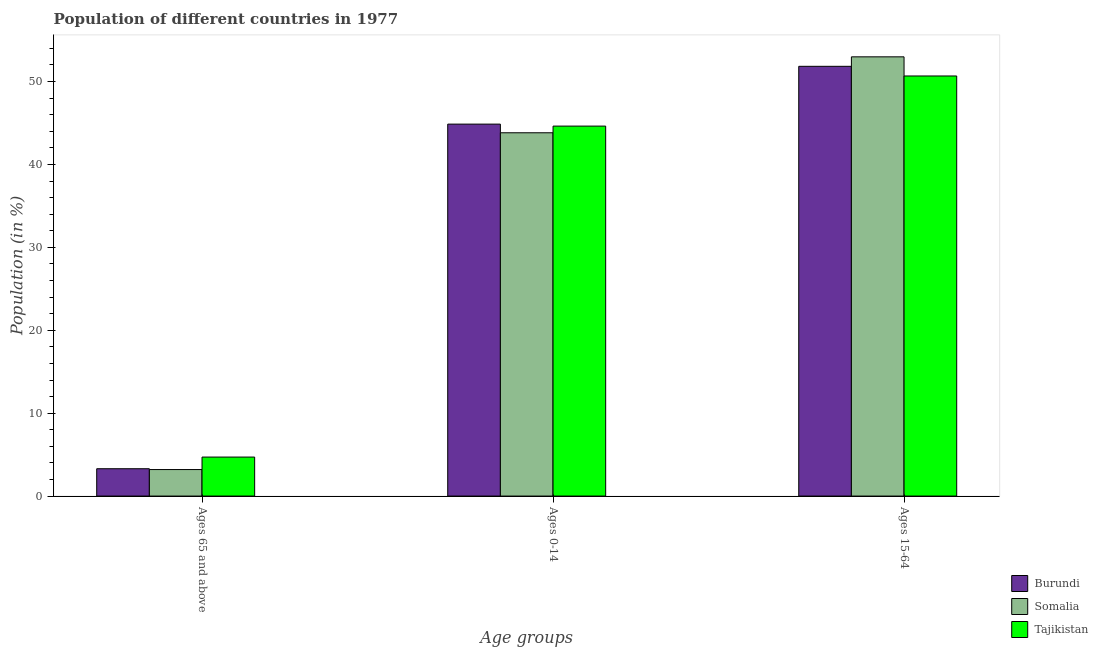How many different coloured bars are there?
Your response must be concise. 3. How many groups of bars are there?
Keep it short and to the point. 3. Are the number of bars per tick equal to the number of legend labels?
Your answer should be compact. Yes. What is the label of the 3rd group of bars from the left?
Keep it short and to the point. Ages 15-64. What is the percentage of population within the age-group 0-14 in Tajikistan?
Offer a terse response. 44.63. Across all countries, what is the maximum percentage of population within the age-group 15-64?
Provide a short and direct response. 52.98. Across all countries, what is the minimum percentage of population within the age-group of 65 and above?
Your response must be concise. 3.2. In which country was the percentage of population within the age-group of 65 and above maximum?
Your response must be concise. Tajikistan. In which country was the percentage of population within the age-group 15-64 minimum?
Provide a succinct answer. Tajikistan. What is the total percentage of population within the age-group 15-64 in the graph?
Offer a very short reply. 155.49. What is the difference between the percentage of population within the age-group 0-14 in Tajikistan and that in Burundi?
Provide a short and direct response. -0.24. What is the difference between the percentage of population within the age-group 0-14 in Somalia and the percentage of population within the age-group of 65 and above in Burundi?
Offer a terse response. 40.52. What is the average percentage of population within the age-group 15-64 per country?
Provide a short and direct response. 51.83. What is the difference between the percentage of population within the age-group 0-14 and percentage of population within the age-group 15-64 in Somalia?
Your response must be concise. -9.16. In how many countries, is the percentage of population within the age-group of 65 and above greater than 18 %?
Provide a short and direct response. 0. What is the ratio of the percentage of population within the age-group 0-14 in Tajikistan to that in Burundi?
Your answer should be compact. 0.99. Is the percentage of population within the age-group 15-64 in Tajikistan less than that in Somalia?
Offer a terse response. Yes. Is the difference between the percentage of population within the age-group 15-64 in Tajikistan and Somalia greater than the difference between the percentage of population within the age-group of 65 and above in Tajikistan and Somalia?
Offer a terse response. No. What is the difference between the highest and the second highest percentage of population within the age-group 15-64?
Offer a very short reply. 1.14. What is the difference between the highest and the lowest percentage of population within the age-group of 65 and above?
Make the answer very short. 1.51. In how many countries, is the percentage of population within the age-group 0-14 greater than the average percentage of population within the age-group 0-14 taken over all countries?
Provide a short and direct response. 2. Is the sum of the percentage of population within the age-group 15-64 in Somalia and Tajikistan greater than the maximum percentage of population within the age-group 0-14 across all countries?
Provide a succinct answer. Yes. What does the 2nd bar from the left in Ages 0-14 represents?
Provide a succinct answer. Somalia. What does the 3rd bar from the right in Ages 15-64 represents?
Provide a succinct answer. Burundi. Is it the case that in every country, the sum of the percentage of population within the age-group of 65 and above and percentage of population within the age-group 0-14 is greater than the percentage of population within the age-group 15-64?
Offer a terse response. No. Are all the bars in the graph horizontal?
Your answer should be compact. No. What is the difference between two consecutive major ticks on the Y-axis?
Offer a terse response. 10. Does the graph contain any zero values?
Make the answer very short. No. Does the graph contain grids?
Your answer should be compact. No. Where does the legend appear in the graph?
Ensure brevity in your answer.  Bottom right. How are the legend labels stacked?
Make the answer very short. Vertical. What is the title of the graph?
Keep it short and to the point. Population of different countries in 1977. What is the label or title of the X-axis?
Keep it short and to the point. Age groups. What is the Population (in %) in Burundi in Ages 65 and above?
Offer a terse response. 3.3. What is the Population (in %) in Somalia in Ages 65 and above?
Offer a very short reply. 3.2. What is the Population (in %) in Tajikistan in Ages 65 and above?
Provide a short and direct response. 4.7. What is the Population (in %) of Burundi in Ages 0-14?
Provide a succinct answer. 44.87. What is the Population (in %) in Somalia in Ages 0-14?
Provide a succinct answer. 43.82. What is the Population (in %) in Tajikistan in Ages 0-14?
Make the answer very short. 44.63. What is the Population (in %) of Burundi in Ages 15-64?
Provide a succinct answer. 51.84. What is the Population (in %) of Somalia in Ages 15-64?
Your answer should be compact. 52.98. What is the Population (in %) of Tajikistan in Ages 15-64?
Offer a very short reply. 50.67. Across all Age groups, what is the maximum Population (in %) of Burundi?
Ensure brevity in your answer.  51.84. Across all Age groups, what is the maximum Population (in %) in Somalia?
Your answer should be very brief. 52.98. Across all Age groups, what is the maximum Population (in %) of Tajikistan?
Your response must be concise. 50.67. Across all Age groups, what is the minimum Population (in %) in Burundi?
Your response must be concise. 3.3. Across all Age groups, what is the minimum Population (in %) in Somalia?
Your answer should be very brief. 3.2. Across all Age groups, what is the minimum Population (in %) of Tajikistan?
Provide a short and direct response. 4.7. What is the total Population (in %) of Burundi in the graph?
Give a very brief answer. 100. What is the total Population (in %) in Somalia in the graph?
Provide a short and direct response. 100. What is the difference between the Population (in %) in Burundi in Ages 65 and above and that in Ages 0-14?
Your answer should be compact. -41.57. What is the difference between the Population (in %) of Somalia in Ages 65 and above and that in Ages 0-14?
Your answer should be compact. -40.62. What is the difference between the Population (in %) in Tajikistan in Ages 65 and above and that in Ages 0-14?
Make the answer very short. -39.92. What is the difference between the Population (in %) of Burundi in Ages 65 and above and that in Ages 15-64?
Keep it short and to the point. -48.54. What is the difference between the Population (in %) in Somalia in Ages 65 and above and that in Ages 15-64?
Offer a very short reply. -49.78. What is the difference between the Population (in %) in Tajikistan in Ages 65 and above and that in Ages 15-64?
Make the answer very short. -45.97. What is the difference between the Population (in %) in Burundi in Ages 0-14 and that in Ages 15-64?
Provide a succinct answer. -6.97. What is the difference between the Population (in %) of Somalia in Ages 0-14 and that in Ages 15-64?
Make the answer very short. -9.16. What is the difference between the Population (in %) of Tajikistan in Ages 0-14 and that in Ages 15-64?
Provide a succinct answer. -6.05. What is the difference between the Population (in %) in Burundi in Ages 65 and above and the Population (in %) in Somalia in Ages 0-14?
Provide a short and direct response. -40.52. What is the difference between the Population (in %) of Burundi in Ages 65 and above and the Population (in %) of Tajikistan in Ages 0-14?
Your response must be concise. -41.33. What is the difference between the Population (in %) in Somalia in Ages 65 and above and the Population (in %) in Tajikistan in Ages 0-14?
Give a very brief answer. -41.43. What is the difference between the Population (in %) in Burundi in Ages 65 and above and the Population (in %) in Somalia in Ages 15-64?
Give a very brief answer. -49.68. What is the difference between the Population (in %) in Burundi in Ages 65 and above and the Population (in %) in Tajikistan in Ages 15-64?
Provide a succinct answer. -47.37. What is the difference between the Population (in %) of Somalia in Ages 65 and above and the Population (in %) of Tajikistan in Ages 15-64?
Offer a terse response. -47.47. What is the difference between the Population (in %) in Burundi in Ages 0-14 and the Population (in %) in Somalia in Ages 15-64?
Keep it short and to the point. -8.11. What is the difference between the Population (in %) in Burundi in Ages 0-14 and the Population (in %) in Tajikistan in Ages 15-64?
Offer a terse response. -5.81. What is the difference between the Population (in %) of Somalia in Ages 0-14 and the Population (in %) of Tajikistan in Ages 15-64?
Offer a terse response. -6.85. What is the average Population (in %) in Burundi per Age groups?
Keep it short and to the point. 33.33. What is the average Population (in %) of Somalia per Age groups?
Provide a short and direct response. 33.33. What is the average Population (in %) of Tajikistan per Age groups?
Offer a very short reply. 33.33. What is the difference between the Population (in %) in Burundi and Population (in %) in Somalia in Ages 65 and above?
Ensure brevity in your answer.  0.1. What is the difference between the Population (in %) of Burundi and Population (in %) of Tajikistan in Ages 65 and above?
Your answer should be compact. -1.41. What is the difference between the Population (in %) in Somalia and Population (in %) in Tajikistan in Ages 65 and above?
Give a very brief answer. -1.51. What is the difference between the Population (in %) of Burundi and Population (in %) of Somalia in Ages 0-14?
Keep it short and to the point. 1.04. What is the difference between the Population (in %) of Burundi and Population (in %) of Tajikistan in Ages 0-14?
Provide a short and direct response. 0.24. What is the difference between the Population (in %) of Somalia and Population (in %) of Tajikistan in Ages 0-14?
Provide a short and direct response. -0.8. What is the difference between the Population (in %) of Burundi and Population (in %) of Somalia in Ages 15-64?
Keep it short and to the point. -1.14. What is the difference between the Population (in %) of Burundi and Population (in %) of Tajikistan in Ages 15-64?
Your response must be concise. 1.17. What is the difference between the Population (in %) of Somalia and Population (in %) of Tajikistan in Ages 15-64?
Make the answer very short. 2.31. What is the ratio of the Population (in %) in Burundi in Ages 65 and above to that in Ages 0-14?
Make the answer very short. 0.07. What is the ratio of the Population (in %) in Somalia in Ages 65 and above to that in Ages 0-14?
Offer a terse response. 0.07. What is the ratio of the Population (in %) in Tajikistan in Ages 65 and above to that in Ages 0-14?
Ensure brevity in your answer.  0.11. What is the ratio of the Population (in %) of Burundi in Ages 65 and above to that in Ages 15-64?
Provide a succinct answer. 0.06. What is the ratio of the Population (in %) of Somalia in Ages 65 and above to that in Ages 15-64?
Your answer should be compact. 0.06. What is the ratio of the Population (in %) in Tajikistan in Ages 65 and above to that in Ages 15-64?
Make the answer very short. 0.09. What is the ratio of the Population (in %) in Burundi in Ages 0-14 to that in Ages 15-64?
Give a very brief answer. 0.87. What is the ratio of the Population (in %) of Somalia in Ages 0-14 to that in Ages 15-64?
Offer a terse response. 0.83. What is the ratio of the Population (in %) in Tajikistan in Ages 0-14 to that in Ages 15-64?
Provide a short and direct response. 0.88. What is the difference between the highest and the second highest Population (in %) of Burundi?
Provide a succinct answer. 6.97. What is the difference between the highest and the second highest Population (in %) in Somalia?
Your answer should be very brief. 9.16. What is the difference between the highest and the second highest Population (in %) in Tajikistan?
Provide a short and direct response. 6.05. What is the difference between the highest and the lowest Population (in %) in Burundi?
Your answer should be very brief. 48.54. What is the difference between the highest and the lowest Population (in %) in Somalia?
Keep it short and to the point. 49.78. What is the difference between the highest and the lowest Population (in %) of Tajikistan?
Ensure brevity in your answer.  45.97. 